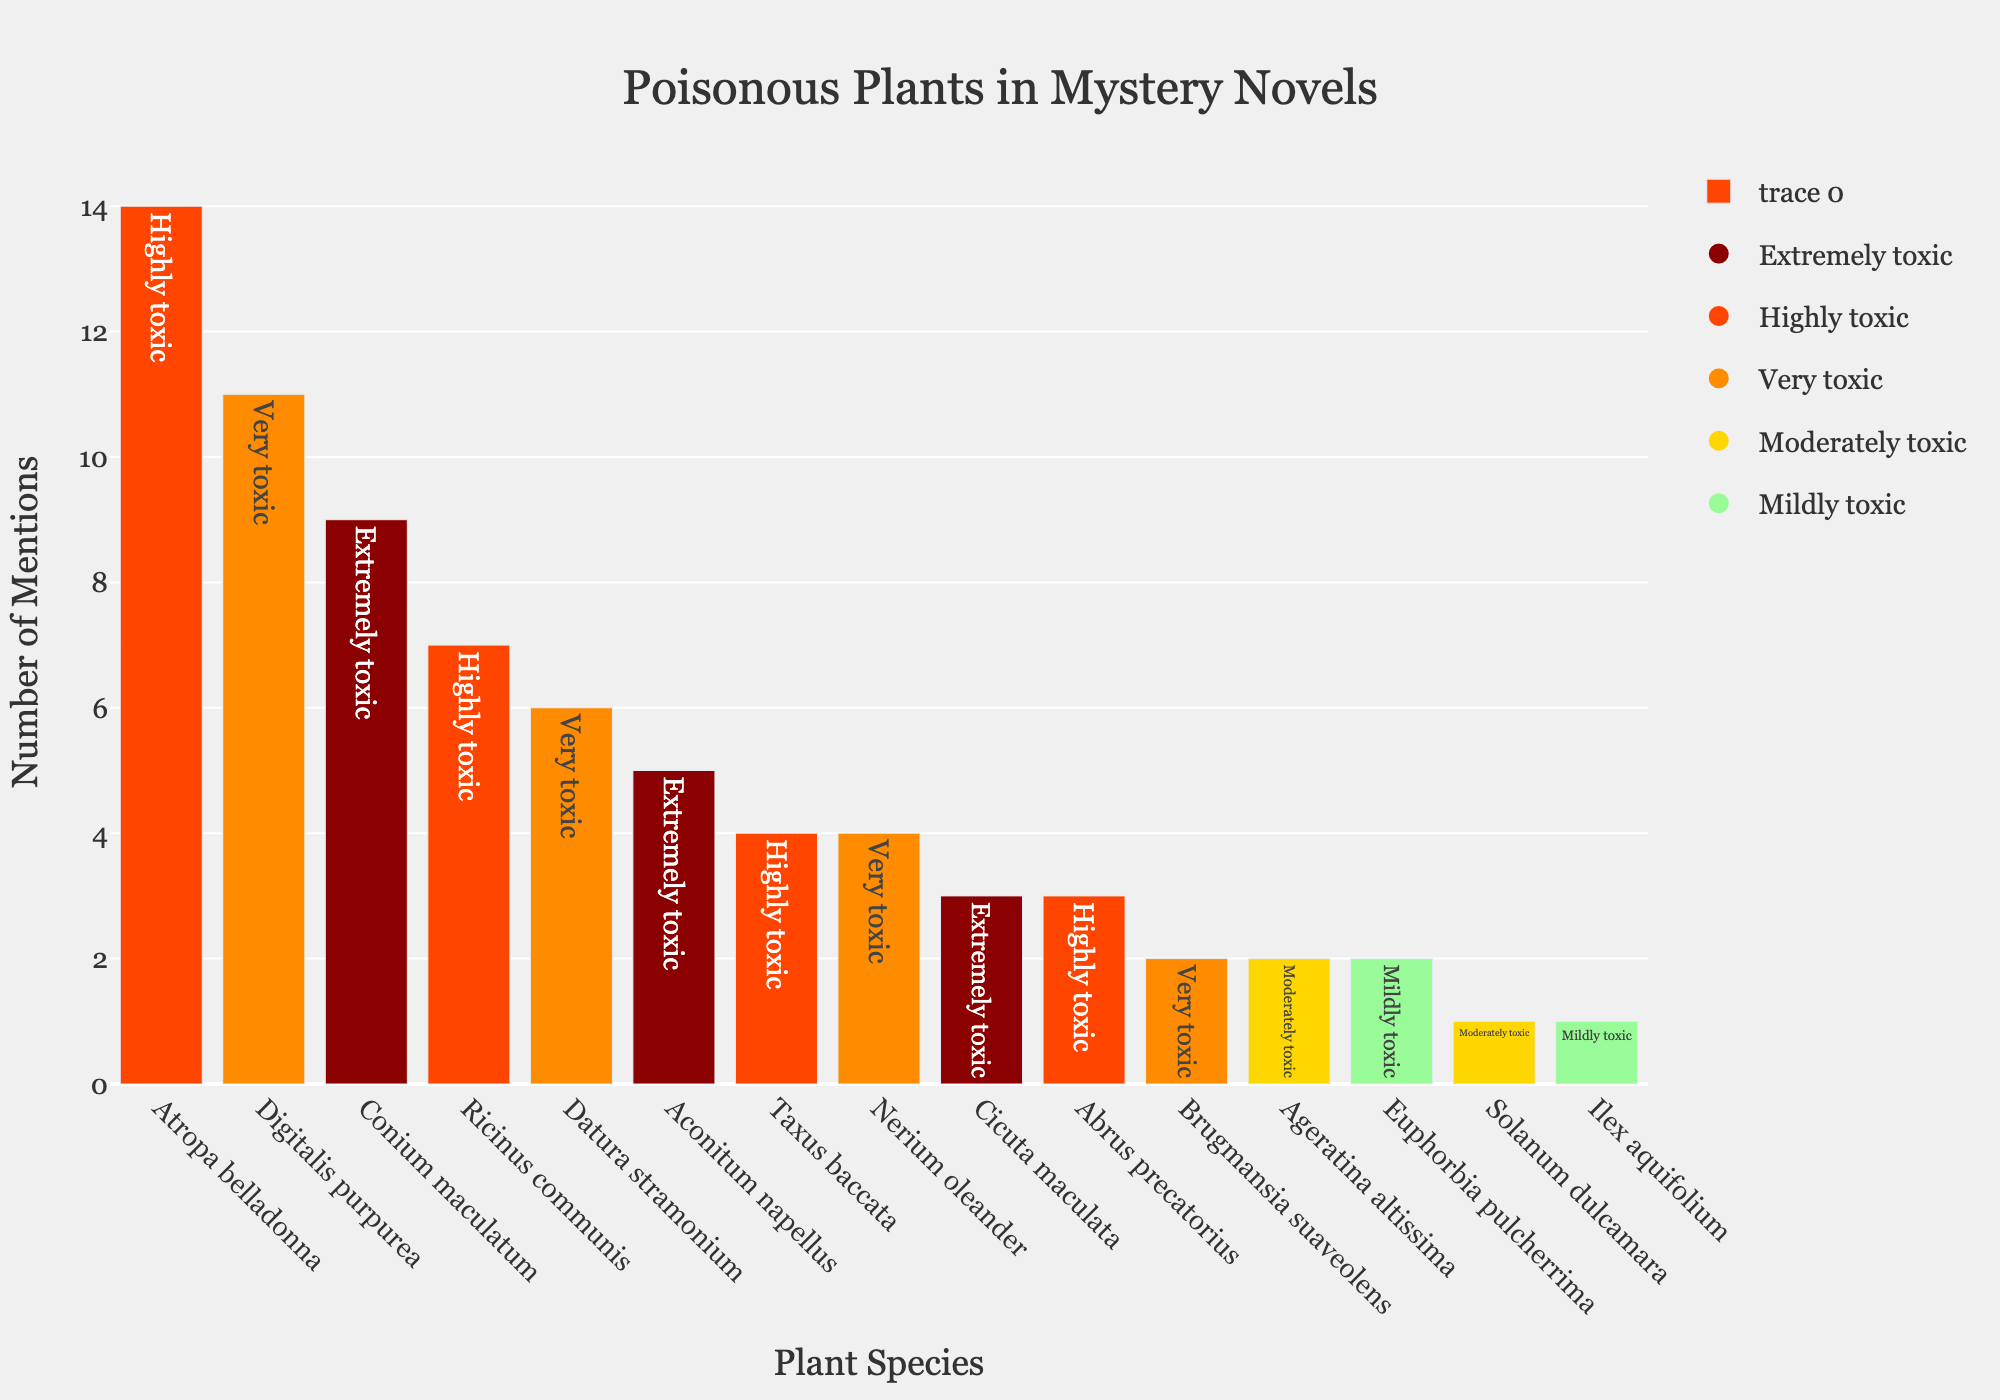What plant is mentioned the most in the mystery series? The y-axis shows the number of mentions, and the tallest bar represents the plant with the most mentions. The tallest bar corresponds to Atropa belladonna.
Answer: Atropa belladonna Which toxicity level has more mentions, "Highly toxic" or "Very toxic"? Sum the mentions for plants under each toxicity level category. "Highly toxic" has mentions of 14 (Atropa belladonna) + 7 (Ricinus communis) + 4 (Taxus baccata) + 3 (Abrus precatorius) = 28. "Very toxic" has mentions of 11 (Digitalis purpurea) + 6 (Datura stramonium) + 4 (Nerium oleander) + 2 (Brugmansia suaveolens) = 23.
Answer: Highly toxic What is the total number of mentions for "Extremely toxic" plants? Sum the mentions for plants under the "Extremely toxic" category. Conium maculatum (9) + Aconitum napellus (5) + Cicuta maculata (3) = 17.
Answer: 17 Which plant with "Very toxic" toxicity level has the least mentions? Check the "Very toxic" category and find the bar with the least height. Brugmansia suaveolens has the least mentions among the "Very toxic" plants.
Answer: Brugmansia suaveolens How many mentions do the top three most frequently mentioned plants have combined? The top three bars are 14 (Atropa belladonna), 11 (Digitalis purpurea), and 9 (Conium maculatum). Add them up: 14 + 11 + 9 = 34.
Answer: 34 Which toxicity level appears the least frequently among the mentioned plants? Count the number of plants under each toxicity level category. "Mildly toxic" has the fewest plants (Euphorbia pulcherrima and Ilex aquifolium, totaling 2 plants).
Answer: Mildly toxic Are there more "Moderately toxic" or "Mildly toxic" plant mentions in the series? Sum the mentions for each category: "Moderately toxic" (Ageratina altissima 2 + Solanum dulcamara 1 = 3), "Mildly toxic" (Euphorbia pulcherrima 2 + Ilex aquifolium 1 = 3). They are equal.
Answer: Equal Which plants fall under the "Highly toxic" category? Identify the bars with the "Highly toxic" color (usually orange or dark red) and list them: Atropa belladonna, Ricinus communis, Taxus baccata, Abrus precatorius.
Answer: Atropa belladonna, Ricinus communis, Taxus baccata, Abrus precatorius 